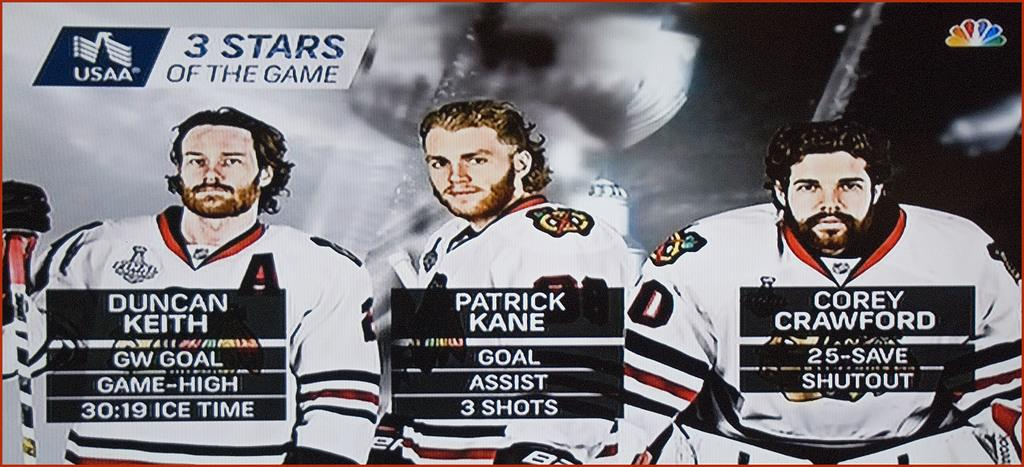Provide a one-sentence caption for the provided image. Hockey coverage says that there were three stars of the game. 